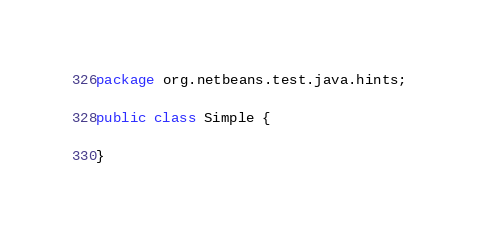Convert code to text. <code><loc_0><loc_0><loc_500><loc_500><_Java_>package org.netbeans.test.java.hints;

public class Simple {
    
}
</code> 